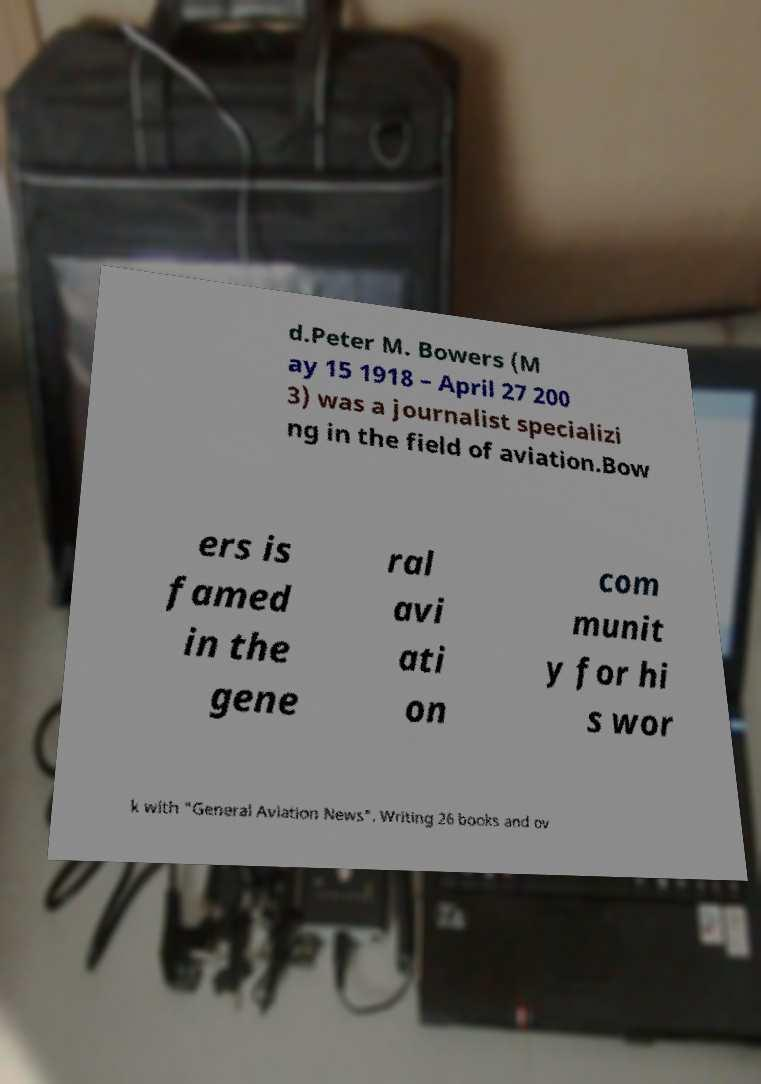Could you extract and type out the text from this image? d.Peter M. Bowers (M ay 15 1918 – April 27 200 3) was a journalist specializi ng in the field of aviation.Bow ers is famed in the gene ral avi ati on com munit y for hi s wor k with "General Aviation News". Writing 26 books and ov 